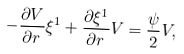Convert formula to latex. <formula><loc_0><loc_0><loc_500><loc_500>- \frac { \partial V } { \partial r } \xi ^ { 1 } + \frac { \partial \xi ^ { 1 } } { \partial r } V = \frac { \psi } { 2 } V ,</formula> 